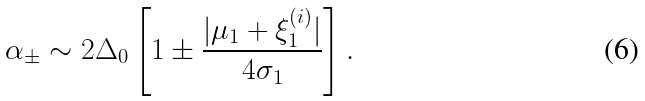<formula> <loc_0><loc_0><loc_500><loc_500>\alpha _ { \pm } \sim 2 \Delta _ { 0 } \left [ 1 \pm \frac { | \mu _ { 1 } + \xi _ { 1 } ^ { ( i ) } | } { 4 \sigma _ { 1 } } \right ] .</formula> 